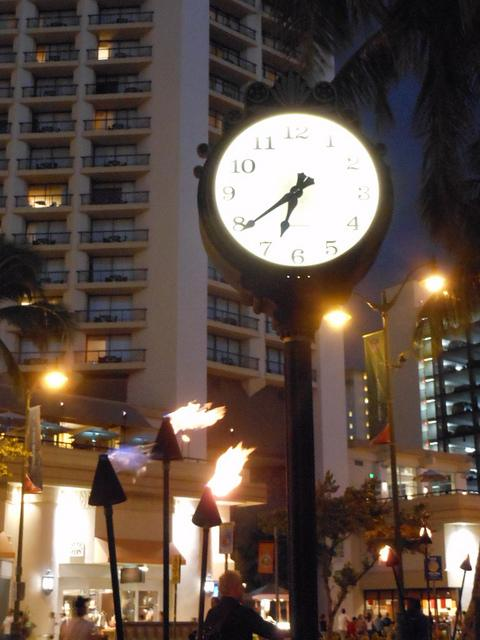In the event of a fire what could be blamed? torches 